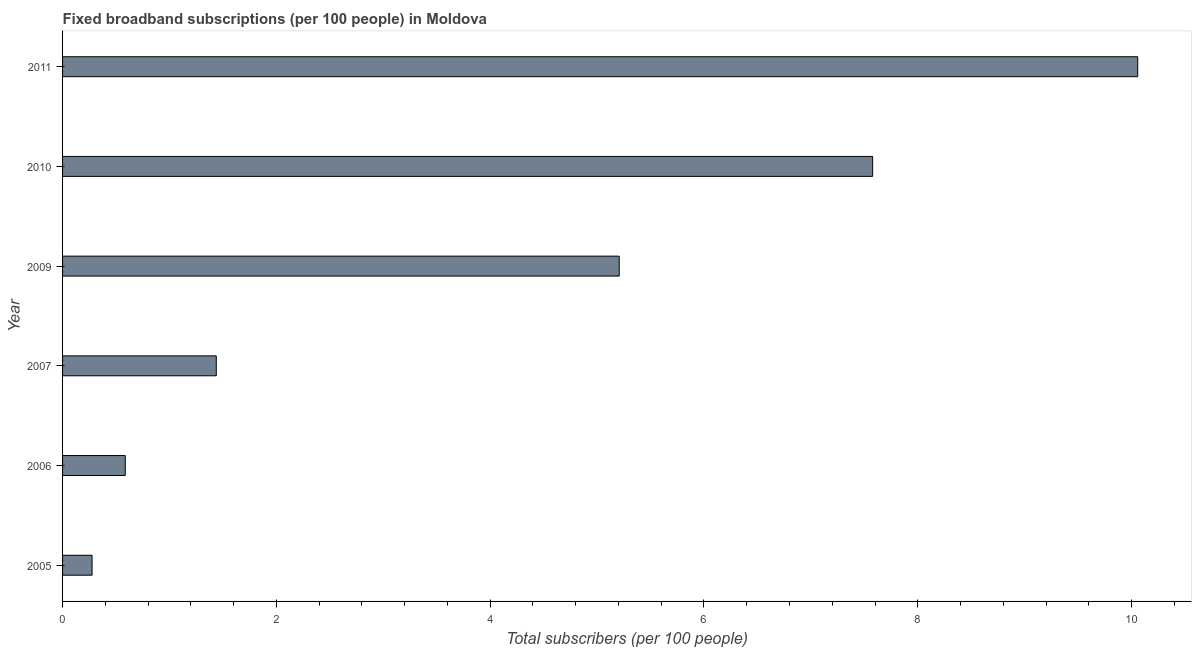Does the graph contain grids?
Ensure brevity in your answer.  No. What is the title of the graph?
Offer a very short reply. Fixed broadband subscriptions (per 100 people) in Moldova. What is the label or title of the X-axis?
Your answer should be compact. Total subscribers (per 100 people). What is the label or title of the Y-axis?
Your answer should be very brief. Year. What is the total number of fixed broadband subscriptions in 2005?
Your answer should be very brief. 0.28. Across all years, what is the maximum total number of fixed broadband subscriptions?
Give a very brief answer. 10.06. Across all years, what is the minimum total number of fixed broadband subscriptions?
Ensure brevity in your answer.  0.28. What is the sum of the total number of fixed broadband subscriptions?
Keep it short and to the point. 25.14. What is the difference between the total number of fixed broadband subscriptions in 2009 and 2011?
Your answer should be very brief. -4.85. What is the average total number of fixed broadband subscriptions per year?
Provide a succinct answer. 4.19. What is the median total number of fixed broadband subscriptions?
Your response must be concise. 3.32. Do a majority of the years between 2009 and 2010 (inclusive) have total number of fixed broadband subscriptions greater than 8.8 ?
Offer a terse response. No. What is the ratio of the total number of fixed broadband subscriptions in 2009 to that in 2010?
Provide a short and direct response. 0.69. Is the total number of fixed broadband subscriptions in 2006 less than that in 2009?
Keep it short and to the point. Yes. Is the difference between the total number of fixed broadband subscriptions in 2007 and 2011 greater than the difference between any two years?
Provide a short and direct response. No. What is the difference between the highest and the second highest total number of fixed broadband subscriptions?
Your answer should be very brief. 2.48. Is the sum of the total number of fixed broadband subscriptions in 2007 and 2010 greater than the maximum total number of fixed broadband subscriptions across all years?
Ensure brevity in your answer.  No. What is the difference between the highest and the lowest total number of fixed broadband subscriptions?
Ensure brevity in your answer.  9.78. Are all the bars in the graph horizontal?
Make the answer very short. Yes. How many years are there in the graph?
Your response must be concise. 6. What is the Total subscribers (per 100 people) of 2005?
Give a very brief answer. 0.28. What is the Total subscribers (per 100 people) in 2006?
Ensure brevity in your answer.  0.59. What is the Total subscribers (per 100 people) in 2007?
Your answer should be compact. 1.44. What is the Total subscribers (per 100 people) of 2009?
Your response must be concise. 5.21. What is the Total subscribers (per 100 people) of 2010?
Provide a succinct answer. 7.58. What is the Total subscribers (per 100 people) of 2011?
Your response must be concise. 10.06. What is the difference between the Total subscribers (per 100 people) in 2005 and 2006?
Offer a terse response. -0.31. What is the difference between the Total subscribers (per 100 people) in 2005 and 2007?
Make the answer very short. -1.16. What is the difference between the Total subscribers (per 100 people) in 2005 and 2009?
Give a very brief answer. -4.93. What is the difference between the Total subscribers (per 100 people) in 2005 and 2010?
Keep it short and to the point. -7.3. What is the difference between the Total subscribers (per 100 people) in 2005 and 2011?
Ensure brevity in your answer.  -9.78. What is the difference between the Total subscribers (per 100 people) in 2006 and 2007?
Your response must be concise. -0.85. What is the difference between the Total subscribers (per 100 people) in 2006 and 2009?
Keep it short and to the point. -4.62. What is the difference between the Total subscribers (per 100 people) in 2006 and 2010?
Keep it short and to the point. -6.99. What is the difference between the Total subscribers (per 100 people) in 2006 and 2011?
Make the answer very short. -9.47. What is the difference between the Total subscribers (per 100 people) in 2007 and 2009?
Your answer should be very brief. -3.77. What is the difference between the Total subscribers (per 100 people) in 2007 and 2010?
Provide a succinct answer. -6.14. What is the difference between the Total subscribers (per 100 people) in 2007 and 2011?
Provide a short and direct response. -8.62. What is the difference between the Total subscribers (per 100 people) in 2009 and 2010?
Keep it short and to the point. -2.37. What is the difference between the Total subscribers (per 100 people) in 2009 and 2011?
Make the answer very short. -4.85. What is the difference between the Total subscribers (per 100 people) in 2010 and 2011?
Provide a succinct answer. -2.48. What is the ratio of the Total subscribers (per 100 people) in 2005 to that in 2006?
Offer a very short reply. 0.47. What is the ratio of the Total subscribers (per 100 people) in 2005 to that in 2007?
Your answer should be very brief. 0.19. What is the ratio of the Total subscribers (per 100 people) in 2005 to that in 2009?
Ensure brevity in your answer.  0.05. What is the ratio of the Total subscribers (per 100 people) in 2005 to that in 2010?
Your answer should be very brief. 0.04. What is the ratio of the Total subscribers (per 100 people) in 2005 to that in 2011?
Offer a terse response. 0.03. What is the ratio of the Total subscribers (per 100 people) in 2006 to that in 2007?
Keep it short and to the point. 0.41. What is the ratio of the Total subscribers (per 100 people) in 2006 to that in 2009?
Offer a very short reply. 0.11. What is the ratio of the Total subscribers (per 100 people) in 2006 to that in 2010?
Give a very brief answer. 0.08. What is the ratio of the Total subscribers (per 100 people) in 2006 to that in 2011?
Your answer should be compact. 0.06. What is the ratio of the Total subscribers (per 100 people) in 2007 to that in 2009?
Give a very brief answer. 0.28. What is the ratio of the Total subscribers (per 100 people) in 2007 to that in 2010?
Your answer should be very brief. 0.19. What is the ratio of the Total subscribers (per 100 people) in 2007 to that in 2011?
Offer a very short reply. 0.14. What is the ratio of the Total subscribers (per 100 people) in 2009 to that in 2010?
Offer a terse response. 0.69. What is the ratio of the Total subscribers (per 100 people) in 2009 to that in 2011?
Provide a succinct answer. 0.52. What is the ratio of the Total subscribers (per 100 people) in 2010 to that in 2011?
Your answer should be very brief. 0.75. 